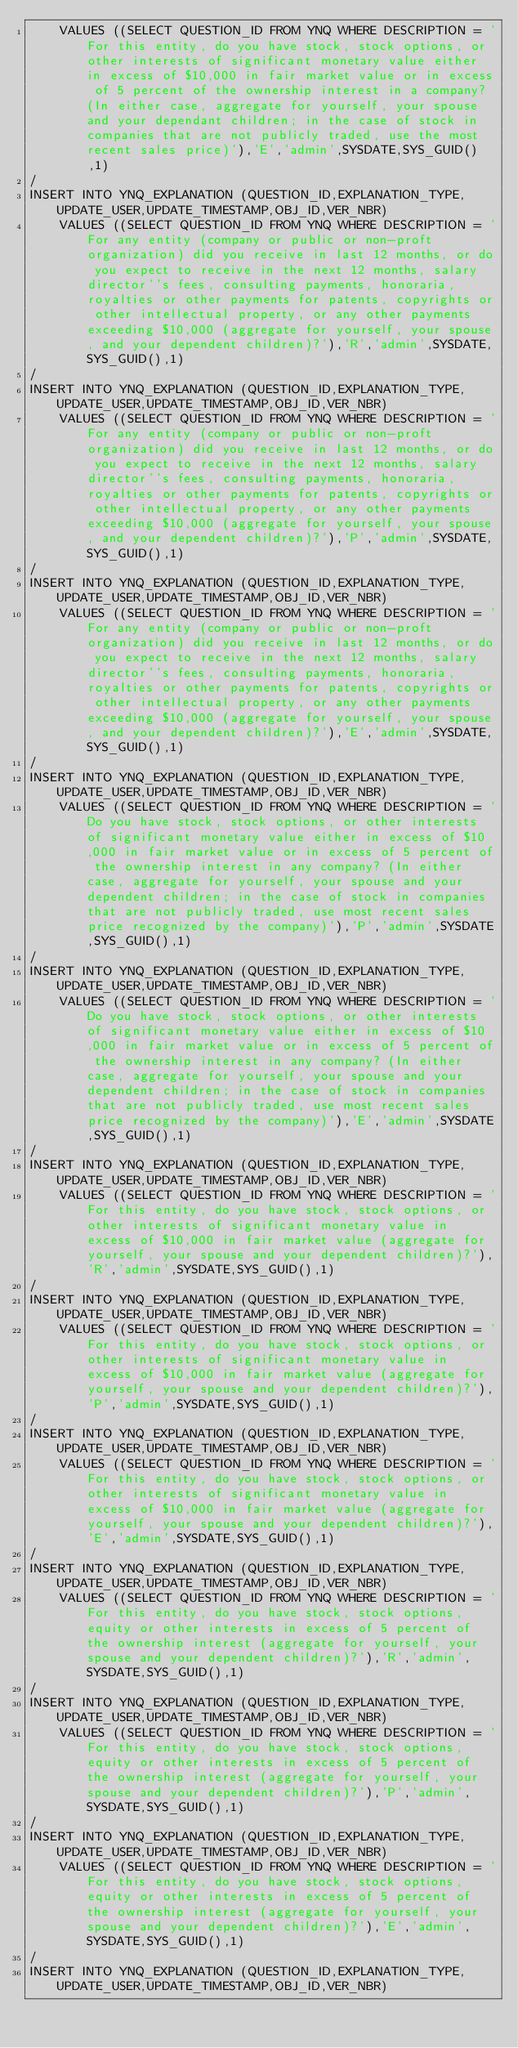<code> <loc_0><loc_0><loc_500><loc_500><_SQL_>    VALUES ((SELECT QUESTION_ID FROM YNQ WHERE DESCRIPTION = 'For this entity, do you have stock, stock options, or other interests of significant monetary value either in excess of $10,000 in fair market value or in excess of 5 percent of the ownership interest in a company? (In either case, aggregate for yourself, your spouse and your dependant children; in the case of stock in companies that are not publicly traded, use the most recent sales price)'),'E','admin',SYSDATE,SYS_GUID(),1)
/
INSERT INTO YNQ_EXPLANATION (QUESTION_ID,EXPLANATION_TYPE,UPDATE_USER,UPDATE_TIMESTAMP,OBJ_ID,VER_NBR) 
    VALUES ((SELECT QUESTION_ID FROM YNQ WHERE DESCRIPTION = 'For any entity (company or public or non-proft organization) did you receive in last 12 months, or do you expect to receive in the next 12 months, salary director''s fees, consulting payments, honoraria, royalties or other payments for patents, copyrights or other intellectual property, or any other payments exceeding $10,000 (aggregate for yourself, your spouse, and your dependent children)?'),'R','admin',SYSDATE,SYS_GUID(),1)
/
INSERT INTO YNQ_EXPLANATION (QUESTION_ID,EXPLANATION_TYPE,UPDATE_USER,UPDATE_TIMESTAMP,OBJ_ID,VER_NBR) 
    VALUES ((SELECT QUESTION_ID FROM YNQ WHERE DESCRIPTION = 'For any entity (company or public or non-proft organization) did you receive in last 12 months, or do you expect to receive in the next 12 months, salary director''s fees, consulting payments, honoraria, royalties or other payments for patents, copyrights or other intellectual property, or any other payments exceeding $10,000 (aggregate for yourself, your spouse, and your dependent children)?'),'P','admin',SYSDATE,SYS_GUID(),1)
/
INSERT INTO YNQ_EXPLANATION (QUESTION_ID,EXPLANATION_TYPE,UPDATE_USER,UPDATE_TIMESTAMP,OBJ_ID,VER_NBR) 
    VALUES ((SELECT QUESTION_ID FROM YNQ WHERE DESCRIPTION = 'For any entity (company or public or non-proft organization) did you receive in last 12 months, or do you expect to receive in the next 12 months, salary director''s fees, consulting payments, honoraria, royalties or other payments for patents, copyrights or other intellectual property, or any other payments exceeding $10,000 (aggregate for yourself, your spouse, and your dependent children)?'),'E','admin',SYSDATE,SYS_GUID(),1)
/
INSERT INTO YNQ_EXPLANATION (QUESTION_ID,EXPLANATION_TYPE,UPDATE_USER,UPDATE_TIMESTAMP,OBJ_ID,VER_NBR) 
    VALUES ((SELECT QUESTION_ID FROM YNQ WHERE DESCRIPTION = 'Do you have stock, stock options, or other interests of significant monetary value either in excess of $10,000 in fair market value or in excess of 5 percent of the ownership interest in any company? (In either case, aggregate for yourself, your spouse and your dependent children; in the case of stock in companies that are not publicly traded, use most recent sales price recognized by the company)'),'P','admin',SYSDATE,SYS_GUID(),1)
/
INSERT INTO YNQ_EXPLANATION (QUESTION_ID,EXPLANATION_TYPE,UPDATE_USER,UPDATE_TIMESTAMP,OBJ_ID,VER_NBR) 
    VALUES ((SELECT QUESTION_ID FROM YNQ WHERE DESCRIPTION = 'Do you have stock, stock options, or other interests of significant monetary value either in excess of $10,000 in fair market value or in excess of 5 percent of the ownership interest in any company? (In either case, aggregate for yourself, your spouse and your dependent children; in the case of stock in companies that are not publicly traded, use most recent sales price recognized by the company)'),'E','admin',SYSDATE,SYS_GUID(),1)
/
INSERT INTO YNQ_EXPLANATION (QUESTION_ID,EXPLANATION_TYPE,UPDATE_USER,UPDATE_TIMESTAMP,OBJ_ID,VER_NBR) 
    VALUES ((SELECT QUESTION_ID FROM YNQ WHERE DESCRIPTION = 'For this entity, do you have stock, stock options, or other interests of significant monetary value in excess of $10,000 in fair market value (aggregate for yourself, your spouse and your dependent children)?'),'R','admin',SYSDATE,SYS_GUID(),1)
/
INSERT INTO YNQ_EXPLANATION (QUESTION_ID,EXPLANATION_TYPE,UPDATE_USER,UPDATE_TIMESTAMP,OBJ_ID,VER_NBR) 
    VALUES ((SELECT QUESTION_ID FROM YNQ WHERE DESCRIPTION = 'For this entity, do you have stock, stock options, or other interests of significant monetary value in excess of $10,000 in fair market value (aggregate for yourself, your spouse and your dependent children)?'),'P','admin',SYSDATE,SYS_GUID(),1)
/
INSERT INTO YNQ_EXPLANATION (QUESTION_ID,EXPLANATION_TYPE,UPDATE_USER,UPDATE_TIMESTAMP,OBJ_ID,VER_NBR) 
    VALUES ((SELECT QUESTION_ID FROM YNQ WHERE DESCRIPTION = 'For this entity, do you have stock, stock options, or other interests of significant monetary value in excess of $10,000 in fair market value (aggregate for yourself, your spouse and your dependent children)?'),'E','admin',SYSDATE,SYS_GUID(),1)
/
INSERT INTO YNQ_EXPLANATION (QUESTION_ID,EXPLANATION_TYPE,UPDATE_USER,UPDATE_TIMESTAMP,OBJ_ID,VER_NBR) 
    VALUES ((SELECT QUESTION_ID FROM YNQ WHERE DESCRIPTION = 'For this entity, do you have stock, stock options, equity or other interests in excess of 5 percent of the ownership interest (aggregate for yourself, your spouse and your dependent children)?'),'R','admin',SYSDATE,SYS_GUID(),1)
/
INSERT INTO YNQ_EXPLANATION (QUESTION_ID,EXPLANATION_TYPE,UPDATE_USER,UPDATE_TIMESTAMP,OBJ_ID,VER_NBR) 
    VALUES ((SELECT QUESTION_ID FROM YNQ WHERE DESCRIPTION = 'For this entity, do you have stock, stock options, equity or other interests in excess of 5 percent of the ownership interest (aggregate for yourself, your spouse and your dependent children)?'),'P','admin',SYSDATE,SYS_GUID(),1)
/
INSERT INTO YNQ_EXPLANATION (QUESTION_ID,EXPLANATION_TYPE,UPDATE_USER,UPDATE_TIMESTAMP,OBJ_ID,VER_NBR) 
    VALUES ((SELECT QUESTION_ID FROM YNQ WHERE DESCRIPTION = 'For this entity, do you have stock, stock options, equity or other interests in excess of 5 percent of the ownership interest (aggregate for yourself, your spouse and your dependent children)?'),'E','admin',SYSDATE,SYS_GUID(),1)
/
INSERT INTO YNQ_EXPLANATION (QUESTION_ID,EXPLANATION_TYPE,UPDATE_USER,UPDATE_TIMESTAMP,OBJ_ID,VER_NBR) </code> 